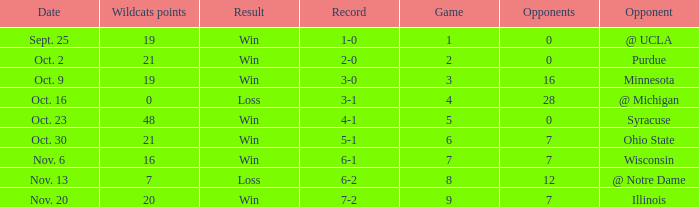What game number did the Wildcats play Purdue? 2.0. 